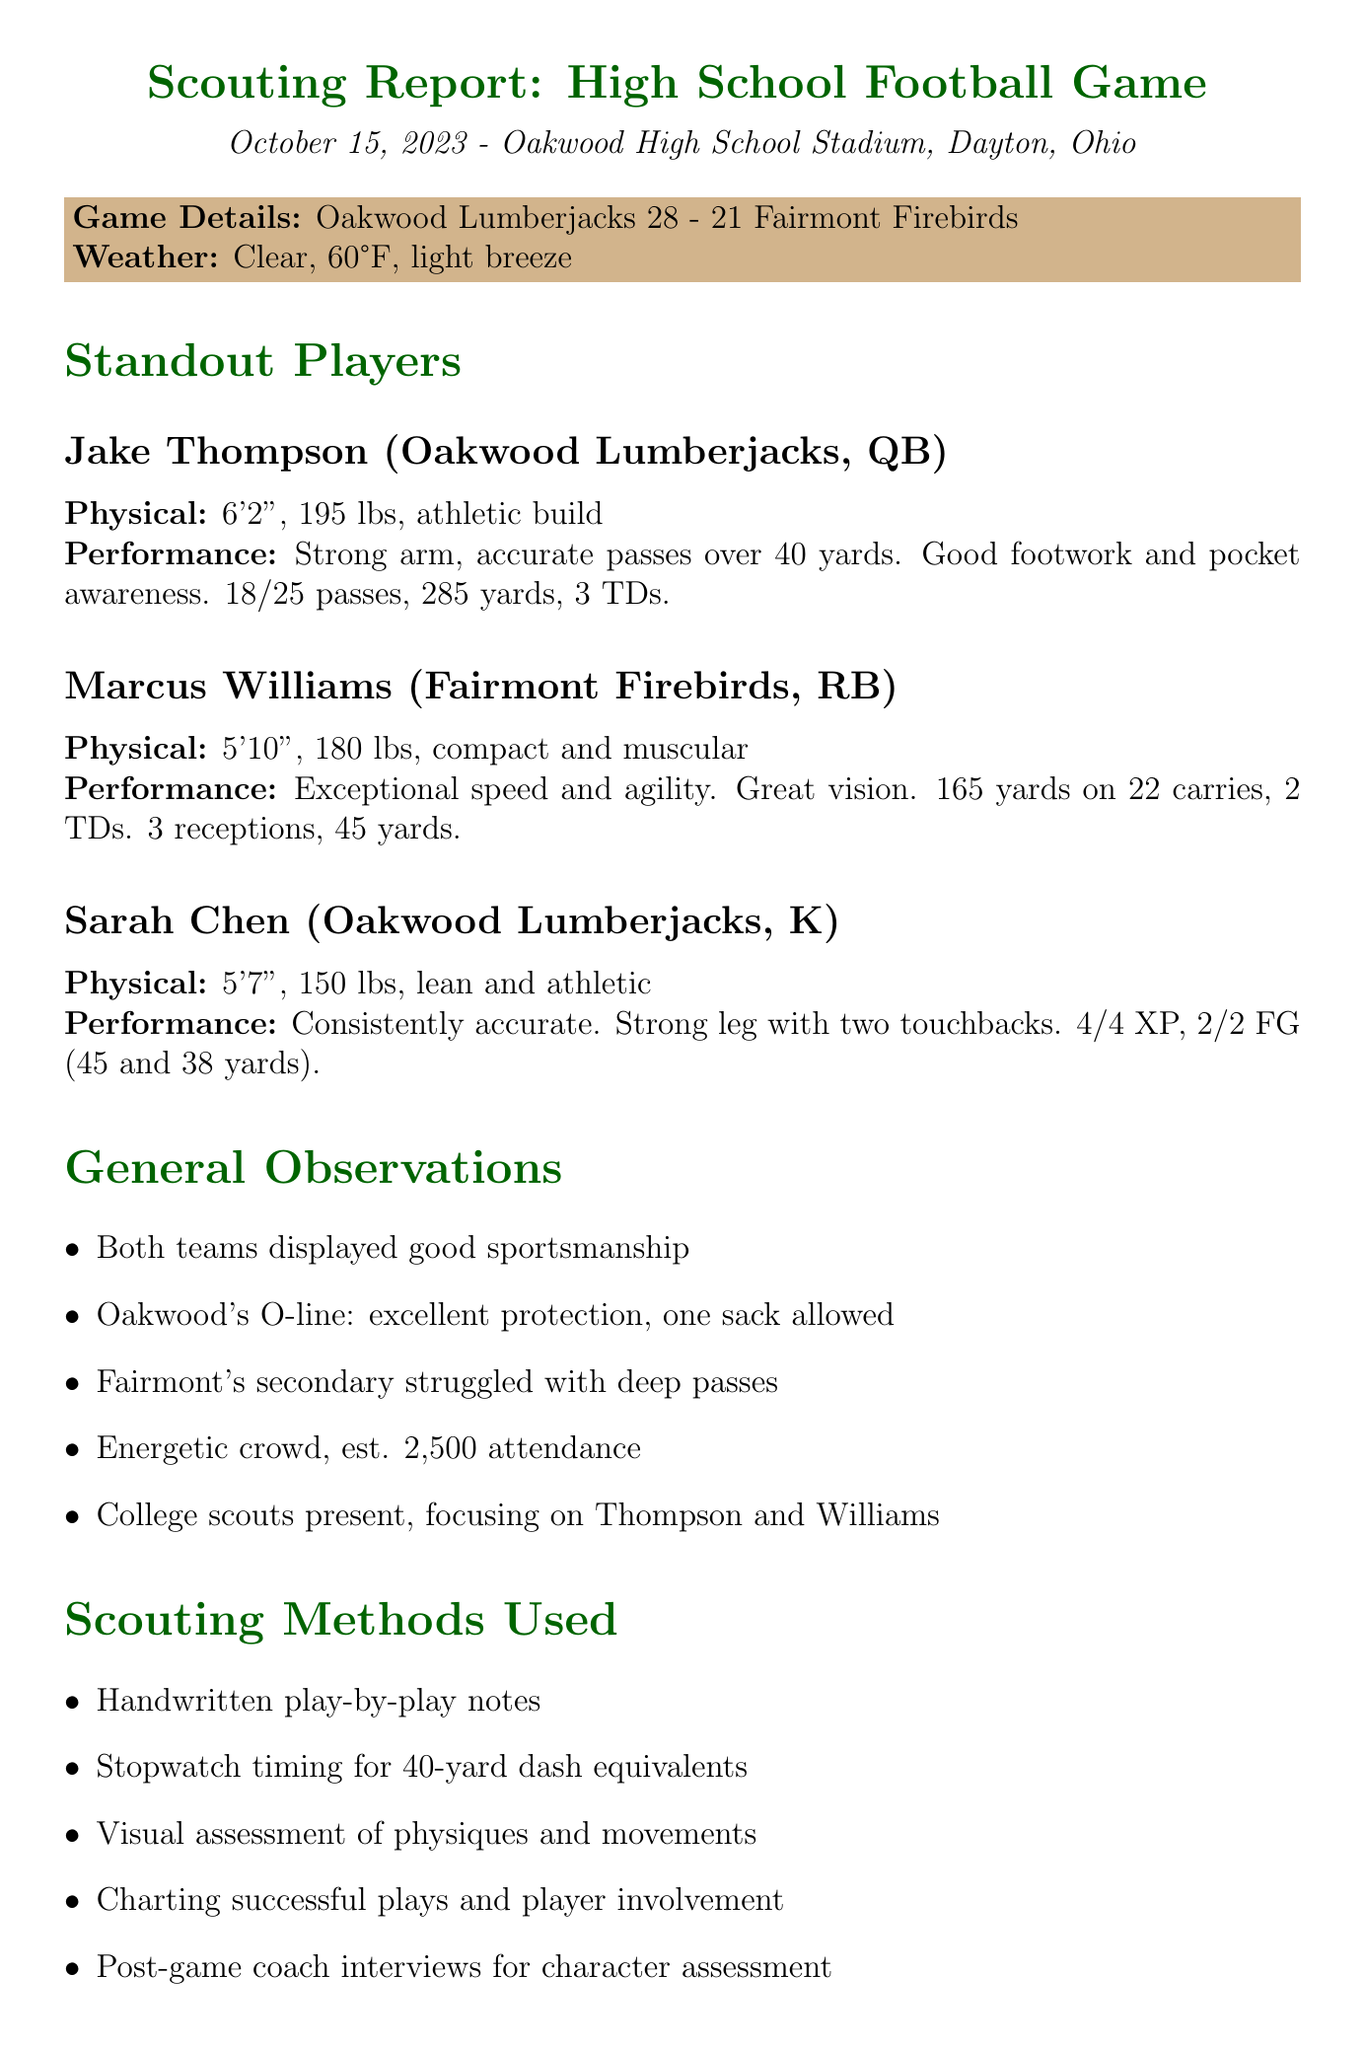What team won the game? The winning team is mentioned in the final score section of the document.
Answer: Oakwood Lumberjacks Who is the quarterback for the Oakwood Lumberjacks? The document lists standout players, specifically mentioning positions and names.
Answer: Jake Thompson How many touchdowns did Marcus Williams score? The performance notes for Marcus Williams provide details on his touchdowns.
Answer: 2 touchdowns What was the attendance at the game? The document includes general observations about the crowd size.
Answer: 2,500 What method was used for timing runs? The scouting methods section details different techniques used during the evaluation.
Answer: Stopwatch timing What specific performance aspect of Jake Thompson needs further evaluation? The areas for further evaluation section highlights aspects related to player performance.
Answer: Performance against stronger defensive lines How many extra points did Sarah Chen successfully make? Sarah Chen's performance notes provide information on her extra points made.
Answer: 4/4 What was the weather condition during the game? The weather conditions are mentioned in the game details section of the document.
Answer: Clear, 60°F, light breeze What was Marcus Williams' rushing yardage? The performance notes for Marcus Williams indicate his rushing statistics.
Answer: 165 yards 